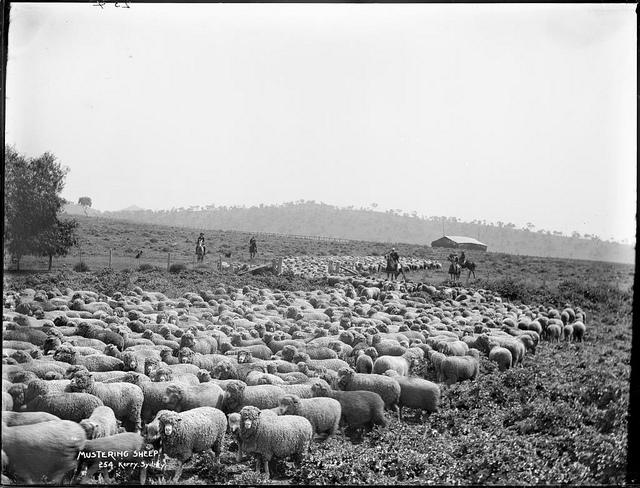How many sheep?
Quick response, please. Many. What animal is being ridden in the background?
Give a very brief answer. Horse. What flock of animals are photographed?
Answer briefly. Sheep. Is this a recent photo?
Give a very brief answer. No. 